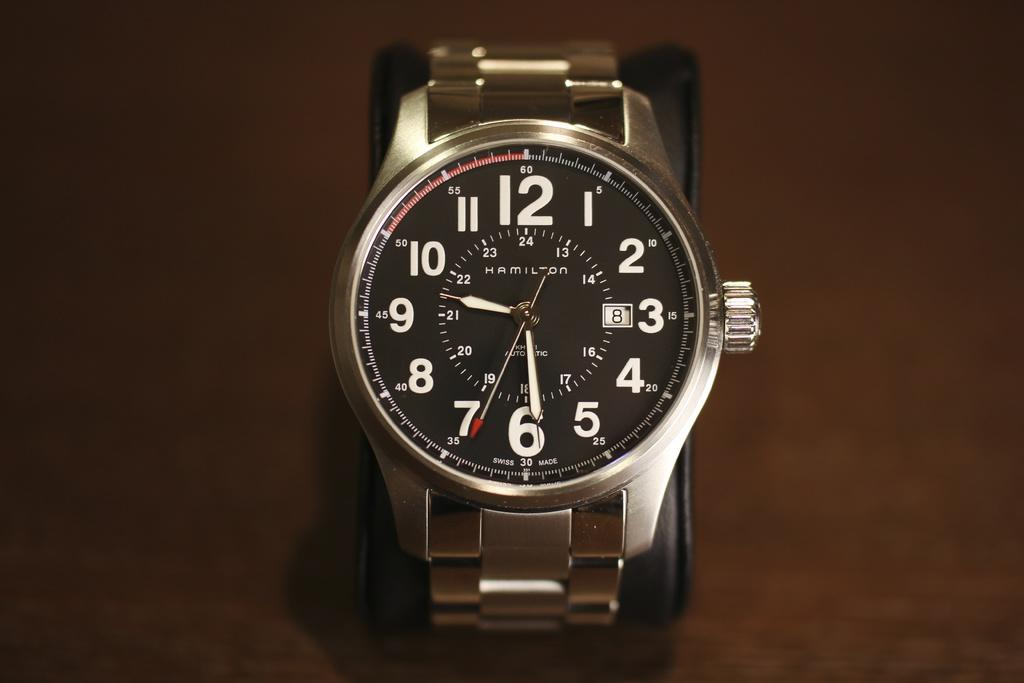<image>
Present a compact description of the photo's key features. Silver wrist watch that has the time and is made from HAMILTON. 